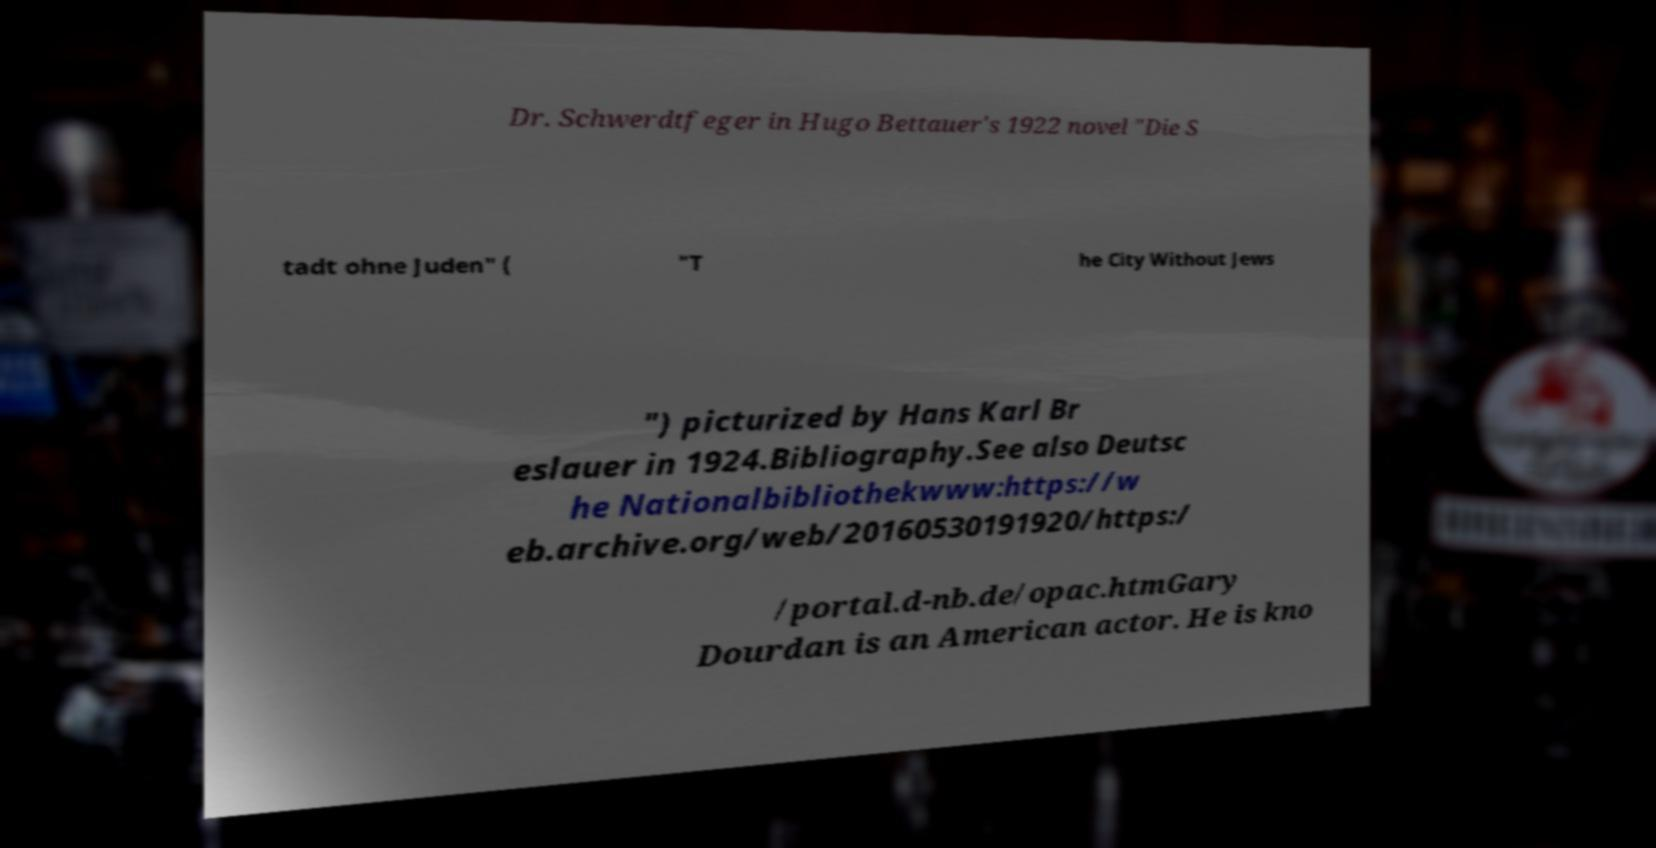Can you accurately transcribe the text from the provided image for me? Dr. Schwerdtfeger in Hugo Bettauer's 1922 novel "Die S tadt ohne Juden" ( "T he City Without Jews ") picturized by Hans Karl Br eslauer in 1924.Bibliography.See also Deutsc he Nationalbibliothekwww:https://w eb.archive.org/web/20160530191920/https:/ /portal.d-nb.de/opac.htmGary Dourdan is an American actor. He is kno 